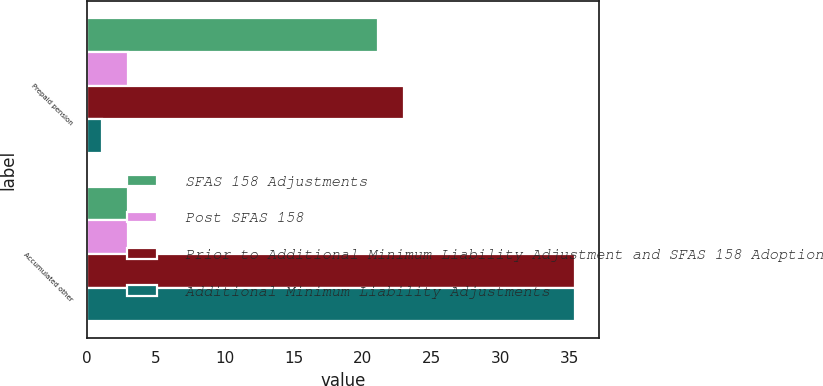<chart> <loc_0><loc_0><loc_500><loc_500><stacked_bar_chart><ecel><fcel>Prepaid pension<fcel>Accumulated other<nl><fcel>SFAS 158 Adjustments<fcel>21.1<fcel>3<nl><fcel>Post SFAS 158<fcel>3<fcel>3<nl><fcel>Prior to Additional Minimum Liability Adjustment and SFAS 158 Adoption<fcel>23<fcel>35.4<nl><fcel>Additional Minimum Liability Adjustments<fcel>1.1<fcel>35.4<nl></chart> 